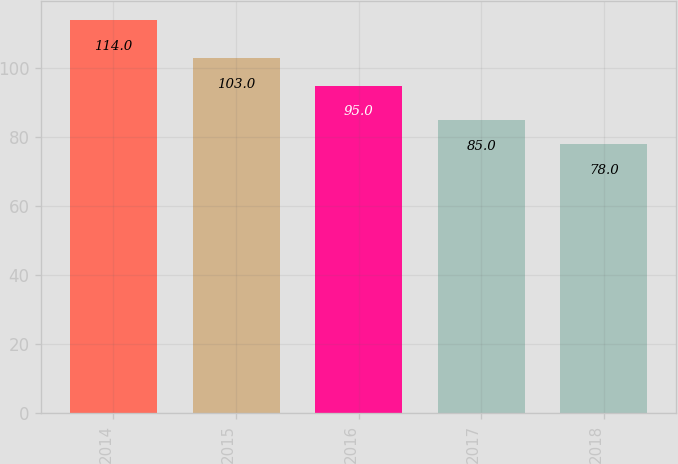Convert chart. <chart><loc_0><loc_0><loc_500><loc_500><bar_chart><fcel>2014<fcel>2015<fcel>2016<fcel>2017<fcel>2018<nl><fcel>114<fcel>103<fcel>95<fcel>85<fcel>78<nl></chart> 